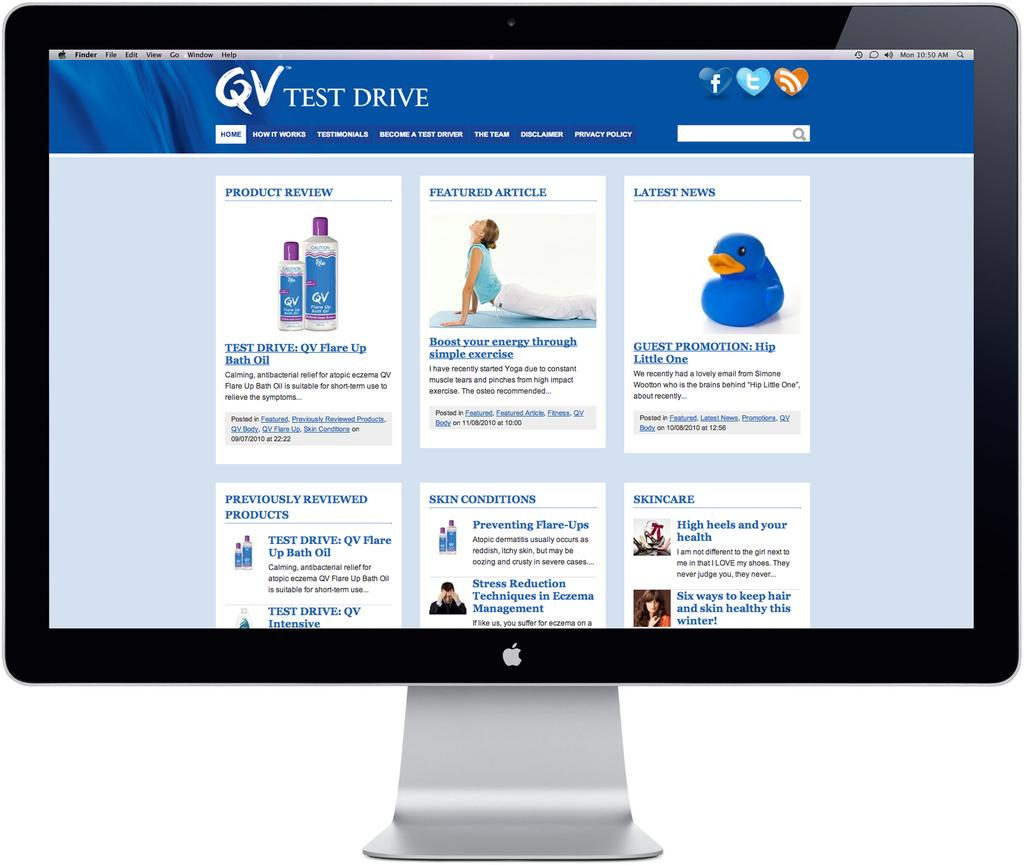<image>
Offer a succinct explanation of the picture presented. The monitor is showing the page for the QV Test Drive. 